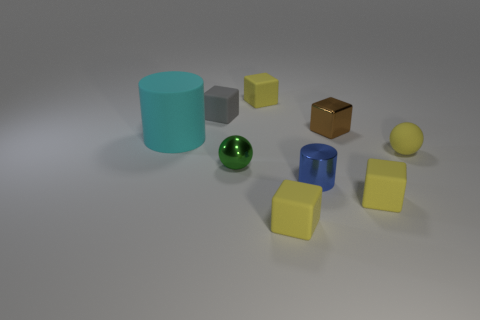Are there any objects in the scene that appear out of place or not in harmony with the rest? All the objects in the scene adhere to a consistent theme of simple geometric shapes like cylinders and spheres. The object that stands out the most is the brown cube on the right. Unlike the other objects, it has a textured surface that resembles wood, which contrasts with the rest of the items that appear to have consistent, solid colors and smoother surfaces. 